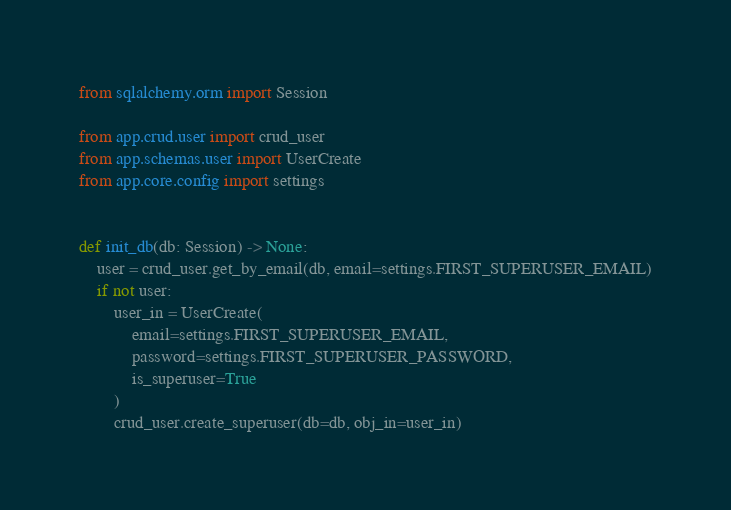Convert code to text. <code><loc_0><loc_0><loc_500><loc_500><_Python_>from sqlalchemy.orm import Session

from app.crud.user import crud_user
from app.schemas.user import UserCreate
from app.core.config import settings


def init_db(db: Session) -> None:
    user = crud_user.get_by_email(db, email=settings.FIRST_SUPERUSER_EMAIL)
    if not user:
        user_in = UserCreate(
            email=settings.FIRST_SUPERUSER_EMAIL,
            password=settings.FIRST_SUPERUSER_PASSWORD,
            is_superuser=True
        )
        crud_user.create_superuser(db=db, obj_in=user_in)
</code> 